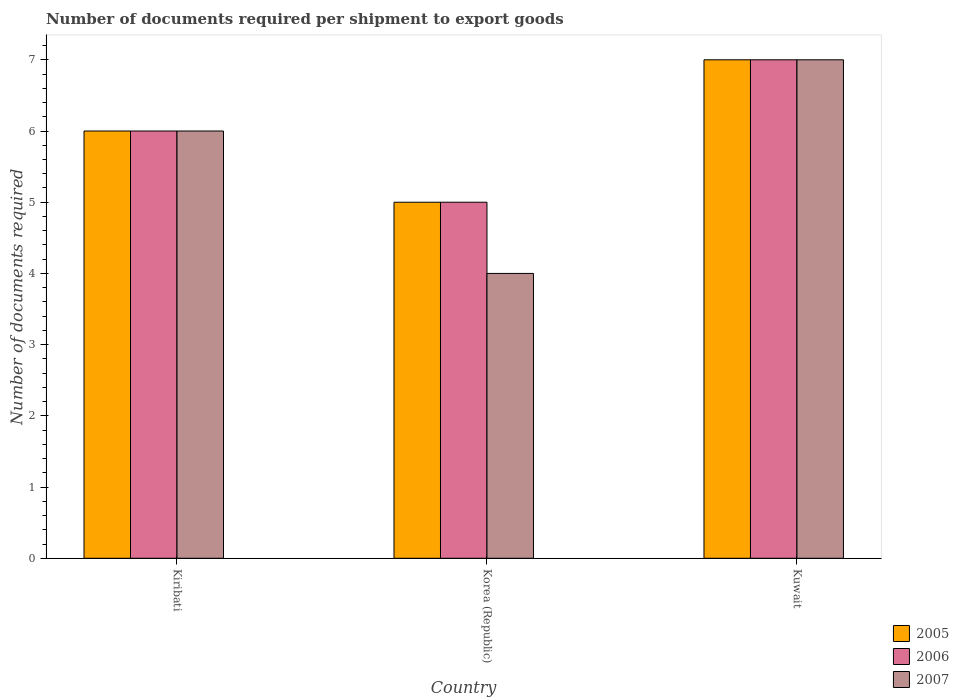How many groups of bars are there?
Your answer should be compact. 3. Are the number of bars per tick equal to the number of legend labels?
Provide a short and direct response. Yes. Are the number of bars on each tick of the X-axis equal?
Ensure brevity in your answer.  Yes. What is the label of the 2nd group of bars from the left?
Provide a succinct answer. Korea (Republic). What is the number of documents required per shipment to export goods in 2006 in Kiribati?
Offer a very short reply. 6. Across all countries, what is the maximum number of documents required per shipment to export goods in 2007?
Give a very brief answer. 7. Across all countries, what is the minimum number of documents required per shipment to export goods in 2007?
Your answer should be very brief. 4. In which country was the number of documents required per shipment to export goods in 2007 maximum?
Provide a short and direct response. Kuwait. What is the difference between the number of documents required per shipment to export goods in 2006 in Kiribati and the number of documents required per shipment to export goods in 2005 in Kuwait?
Your answer should be compact. -1. What is the difference between the number of documents required per shipment to export goods of/in 2005 and number of documents required per shipment to export goods of/in 2007 in Kiribati?
Give a very brief answer. 0. In how many countries, is the number of documents required per shipment to export goods in 2006 greater than 3.4?
Your answer should be very brief. 3. What is the ratio of the number of documents required per shipment to export goods in 2005 in Korea (Republic) to that in Kuwait?
Provide a succinct answer. 0.71. Is the number of documents required per shipment to export goods in 2007 in Kiribati less than that in Korea (Republic)?
Provide a succinct answer. No. Is the sum of the number of documents required per shipment to export goods in 2007 in Kiribati and Kuwait greater than the maximum number of documents required per shipment to export goods in 2005 across all countries?
Your answer should be very brief. Yes. What does the 2nd bar from the left in Kiribati represents?
Provide a short and direct response. 2006. What does the 3rd bar from the right in Kiribati represents?
Your answer should be compact. 2005. How many bars are there?
Provide a succinct answer. 9. Are all the bars in the graph horizontal?
Offer a terse response. No. How many countries are there in the graph?
Provide a short and direct response. 3. What is the difference between two consecutive major ticks on the Y-axis?
Offer a terse response. 1. Does the graph contain any zero values?
Keep it short and to the point. No. Where does the legend appear in the graph?
Offer a terse response. Bottom right. How many legend labels are there?
Your response must be concise. 3. What is the title of the graph?
Your response must be concise. Number of documents required per shipment to export goods. What is the label or title of the X-axis?
Provide a succinct answer. Country. What is the label or title of the Y-axis?
Provide a short and direct response. Number of documents required. What is the Number of documents required in 2006 in Kiribati?
Keep it short and to the point. 6. What is the Number of documents required in 2007 in Korea (Republic)?
Provide a short and direct response. 4. What is the Number of documents required in 2005 in Kuwait?
Make the answer very short. 7. What is the Number of documents required in 2006 in Kuwait?
Your response must be concise. 7. What is the Number of documents required of 2007 in Kuwait?
Ensure brevity in your answer.  7. Across all countries, what is the minimum Number of documents required in 2005?
Ensure brevity in your answer.  5. What is the total Number of documents required of 2006 in the graph?
Provide a succinct answer. 18. What is the total Number of documents required in 2007 in the graph?
Your response must be concise. 17. What is the difference between the Number of documents required in 2006 in Kiribati and that in Korea (Republic)?
Keep it short and to the point. 1. What is the difference between the Number of documents required in 2005 in Korea (Republic) and that in Kuwait?
Provide a succinct answer. -2. What is the difference between the Number of documents required in 2006 in Korea (Republic) and that in Kuwait?
Provide a short and direct response. -2. What is the difference between the Number of documents required in 2007 in Korea (Republic) and that in Kuwait?
Make the answer very short. -3. What is the difference between the Number of documents required in 2005 in Kiribati and the Number of documents required in 2006 in Korea (Republic)?
Provide a short and direct response. 1. What is the difference between the Number of documents required in 2006 in Kiribati and the Number of documents required in 2007 in Korea (Republic)?
Give a very brief answer. 2. What is the difference between the Number of documents required in 2005 in Kiribati and the Number of documents required in 2006 in Kuwait?
Ensure brevity in your answer.  -1. What is the average Number of documents required in 2007 per country?
Your response must be concise. 5.67. What is the difference between the Number of documents required of 2006 and Number of documents required of 2007 in Kiribati?
Give a very brief answer. 0. What is the difference between the Number of documents required of 2006 and Number of documents required of 2007 in Kuwait?
Provide a succinct answer. 0. What is the ratio of the Number of documents required in 2005 in Kiribati to that in Korea (Republic)?
Your response must be concise. 1.2. What is the ratio of the Number of documents required of 2005 in Kiribati to that in Kuwait?
Keep it short and to the point. 0.86. What is the ratio of the Number of documents required in 2005 in Korea (Republic) to that in Kuwait?
Give a very brief answer. 0.71. What is the difference between the highest and the second highest Number of documents required in 2005?
Your answer should be compact. 1. What is the difference between the highest and the second highest Number of documents required in 2006?
Keep it short and to the point. 1. What is the difference between the highest and the second highest Number of documents required of 2007?
Offer a very short reply. 1. What is the difference between the highest and the lowest Number of documents required in 2007?
Provide a short and direct response. 3. 